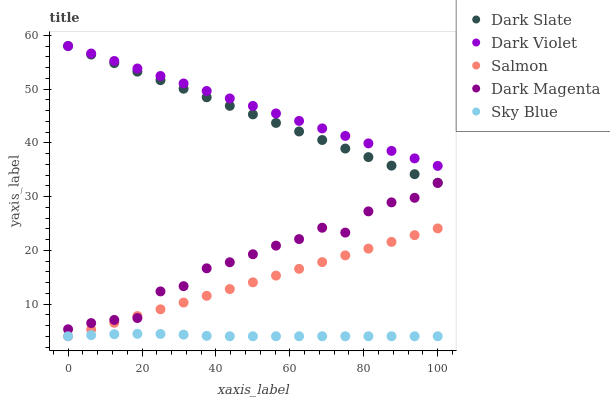Does Sky Blue have the minimum area under the curve?
Answer yes or no. Yes. Does Dark Violet have the maximum area under the curve?
Answer yes or no. Yes. Does Salmon have the minimum area under the curve?
Answer yes or no. No. Does Salmon have the maximum area under the curve?
Answer yes or no. No. Is Salmon the smoothest?
Answer yes or no. Yes. Is Dark Magenta the roughest?
Answer yes or no. Yes. Is Dark Magenta the smoothest?
Answer yes or no. No. Is Salmon the roughest?
Answer yes or no. No. Does Salmon have the lowest value?
Answer yes or no. Yes. Does Dark Magenta have the lowest value?
Answer yes or no. No. Does Dark Violet have the highest value?
Answer yes or no. Yes. Does Salmon have the highest value?
Answer yes or no. No. Is Salmon less than Dark Violet?
Answer yes or no. Yes. Is Dark Violet greater than Sky Blue?
Answer yes or no. Yes. Does Dark Violet intersect Dark Slate?
Answer yes or no. Yes. Is Dark Violet less than Dark Slate?
Answer yes or no. No. Is Dark Violet greater than Dark Slate?
Answer yes or no. No. Does Salmon intersect Dark Violet?
Answer yes or no. No. 